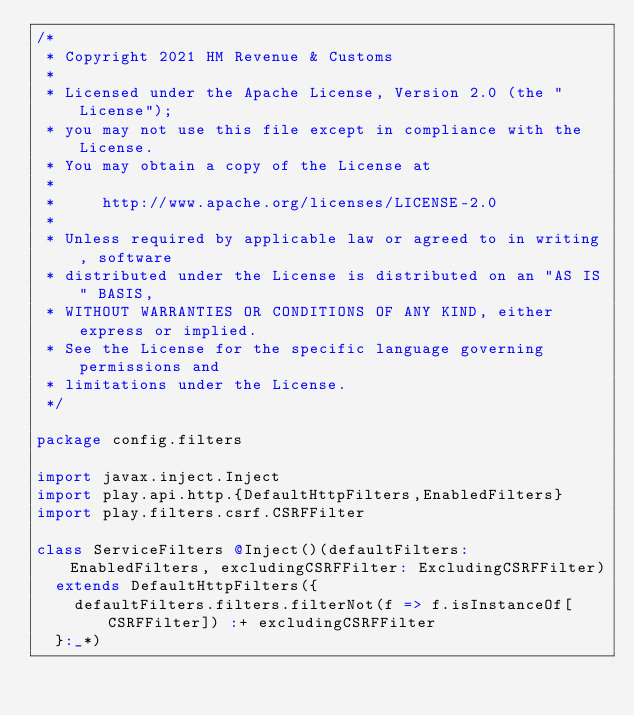<code> <loc_0><loc_0><loc_500><loc_500><_Scala_>/*
 * Copyright 2021 HM Revenue & Customs
 *
 * Licensed under the Apache License, Version 2.0 (the "License");
 * you may not use this file except in compliance with the License.
 * You may obtain a copy of the License at
 *
 *     http://www.apache.org/licenses/LICENSE-2.0
 *
 * Unless required by applicable law or agreed to in writing, software
 * distributed under the License is distributed on an "AS IS" BASIS,
 * WITHOUT WARRANTIES OR CONDITIONS OF ANY KIND, either express or implied.
 * See the License for the specific language governing permissions and
 * limitations under the License.
 */

package config.filters

import javax.inject.Inject
import play.api.http.{DefaultHttpFilters,EnabledFilters}
import play.filters.csrf.CSRFFilter

class ServiceFilters @Inject()(defaultFilters: EnabledFilters, excludingCSRFFilter: ExcludingCSRFFilter)
  extends DefaultHttpFilters({
    defaultFilters.filters.filterNot(f => f.isInstanceOf[CSRFFilter]) :+ excludingCSRFFilter
  }:_*)
</code> 